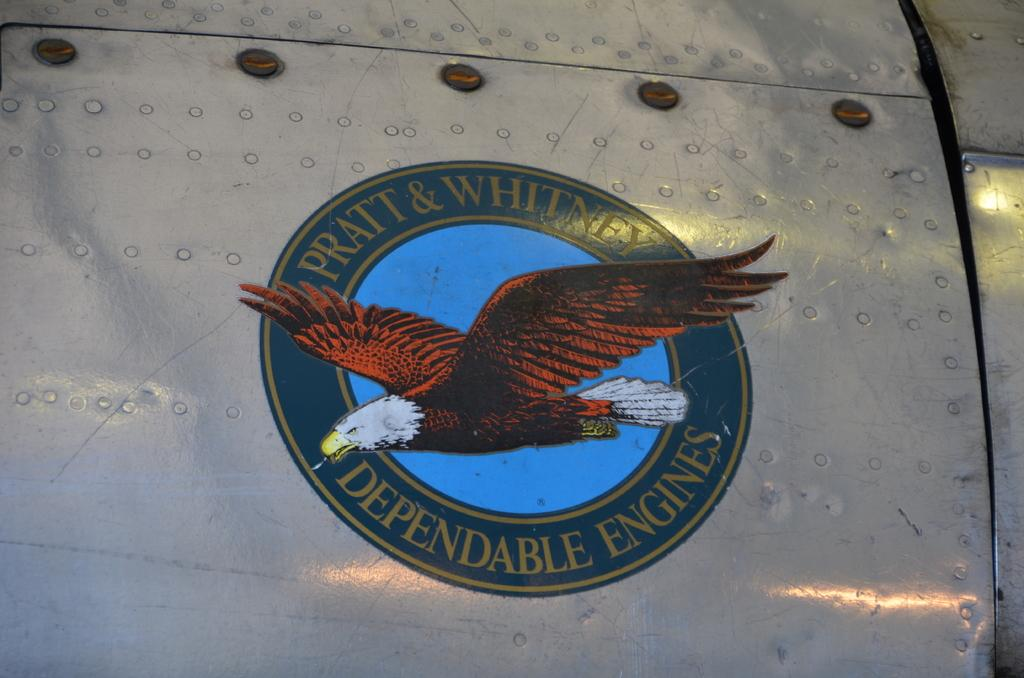What is the main subject of the image? The main subject of the image is an eagle logo. What material is the eagle logo placed on? The eagle logo is present on a metal sheet. What type of brick is used to construct the wren's nest in the image? There is no wren or nest present in the image, and therefore no such construction can be observed. What type of prose is written on the metal sheet in the image? There is no prose present on the metal sheet in the image; it only features the eagle logo. 